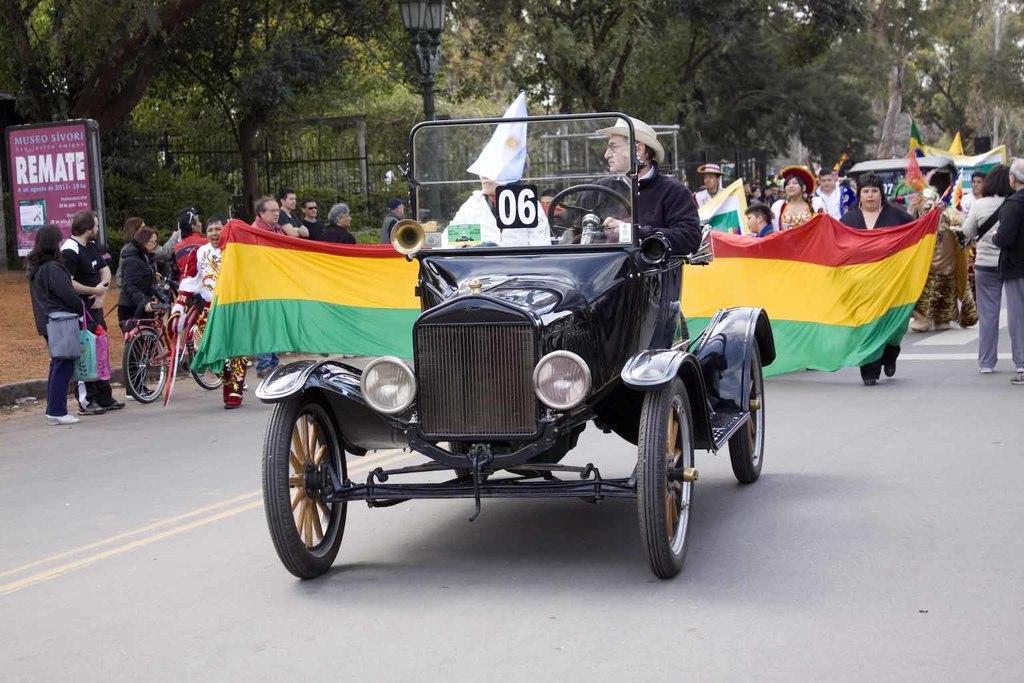Describe this image in one or two sentences. In this image at the center there are vehicles on the road. Few people are running by holding the banner. At the left side of the image there is a board and we can see people are standing. At the background there are trees. We can see there is a street light at the left side of the image. 